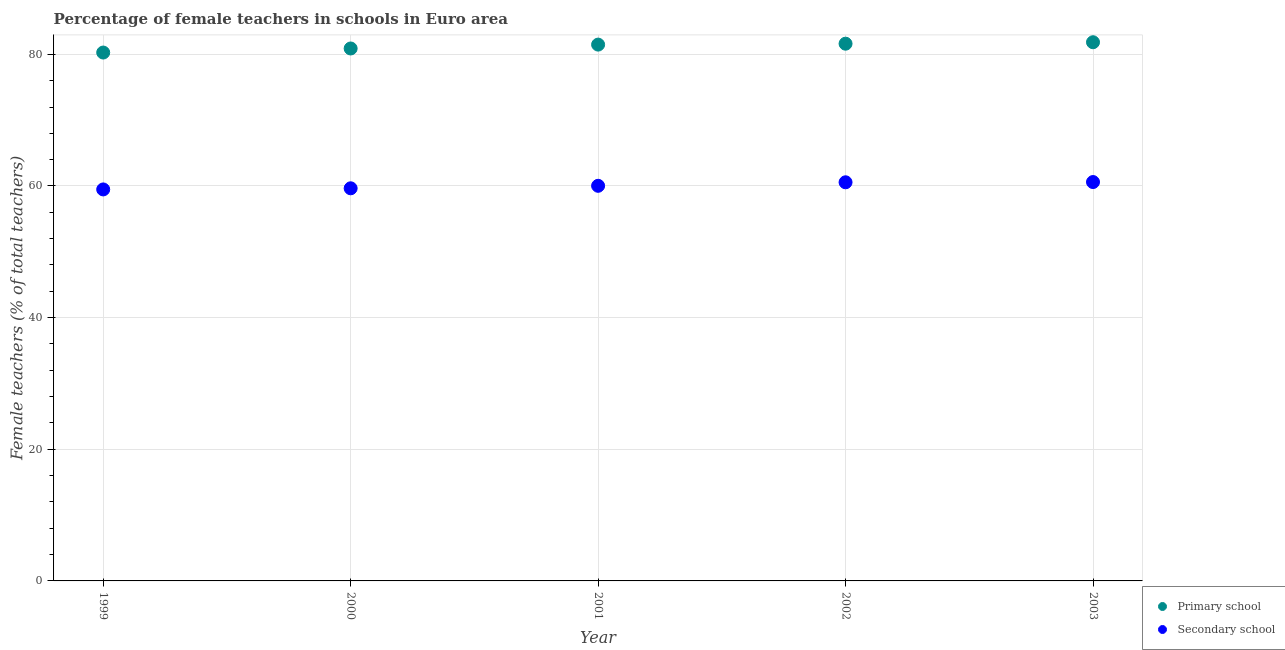What is the percentage of female teachers in secondary schools in 2002?
Your answer should be very brief. 60.56. Across all years, what is the maximum percentage of female teachers in secondary schools?
Keep it short and to the point. 60.6. Across all years, what is the minimum percentage of female teachers in secondary schools?
Your response must be concise. 59.48. What is the total percentage of female teachers in secondary schools in the graph?
Offer a terse response. 300.32. What is the difference between the percentage of female teachers in secondary schools in 2001 and that in 2002?
Your answer should be very brief. -0.53. What is the difference between the percentage of female teachers in secondary schools in 1999 and the percentage of female teachers in primary schools in 2000?
Your response must be concise. -21.41. What is the average percentage of female teachers in primary schools per year?
Offer a terse response. 81.22. In the year 2003, what is the difference between the percentage of female teachers in primary schools and percentage of female teachers in secondary schools?
Keep it short and to the point. 21.24. In how many years, is the percentage of female teachers in primary schools greater than 48 %?
Offer a very short reply. 5. What is the ratio of the percentage of female teachers in secondary schools in 2000 to that in 2003?
Provide a short and direct response. 0.98. Is the percentage of female teachers in secondary schools in 2000 less than that in 2001?
Provide a short and direct response. Yes. Is the difference between the percentage of female teachers in primary schools in 1999 and 2000 greater than the difference between the percentage of female teachers in secondary schools in 1999 and 2000?
Give a very brief answer. No. What is the difference between the highest and the second highest percentage of female teachers in primary schools?
Ensure brevity in your answer.  0.22. What is the difference between the highest and the lowest percentage of female teachers in secondary schools?
Provide a short and direct response. 1.12. In how many years, is the percentage of female teachers in secondary schools greater than the average percentage of female teachers in secondary schools taken over all years?
Provide a short and direct response. 2. Does the percentage of female teachers in secondary schools monotonically increase over the years?
Provide a short and direct response. Yes. Is the percentage of female teachers in primary schools strictly less than the percentage of female teachers in secondary schools over the years?
Provide a succinct answer. No. Are the values on the major ticks of Y-axis written in scientific E-notation?
Your answer should be compact. No. Does the graph contain any zero values?
Ensure brevity in your answer.  No. Where does the legend appear in the graph?
Provide a short and direct response. Bottom right. What is the title of the graph?
Give a very brief answer. Percentage of female teachers in schools in Euro area. What is the label or title of the Y-axis?
Your response must be concise. Female teachers (% of total teachers). What is the Female teachers (% of total teachers) in Primary school in 1999?
Provide a succinct answer. 80.27. What is the Female teachers (% of total teachers) of Secondary school in 1999?
Your answer should be compact. 59.48. What is the Female teachers (% of total teachers) in Primary school in 2000?
Keep it short and to the point. 80.89. What is the Female teachers (% of total teachers) in Secondary school in 2000?
Ensure brevity in your answer.  59.65. What is the Female teachers (% of total teachers) of Primary school in 2001?
Make the answer very short. 81.48. What is the Female teachers (% of total teachers) of Secondary school in 2001?
Your answer should be very brief. 60.03. What is the Female teachers (% of total teachers) in Primary school in 2002?
Your answer should be very brief. 81.62. What is the Female teachers (% of total teachers) of Secondary school in 2002?
Make the answer very short. 60.56. What is the Female teachers (% of total teachers) in Primary school in 2003?
Ensure brevity in your answer.  81.84. What is the Female teachers (% of total teachers) of Secondary school in 2003?
Ensure brevity in your answer.  60.6. Across all years, what is the maximum Female teachers (% of total teachers) of Primary school?
Your answer should be compact. 81.84. Across all years, what is the maximum Female teachers (% of total teachers) in Secondary school?
Your response must be concise. 60.6. Across all years, what is the minimum Female teachers (% of total teachers) in Primary school?
Give a very brief answer. 80.27. Across all years, what is the minimum Female teachers (% of total teachers) in Secondary school?
Offer a very short reply. 59.48. What is the total Female teachers (% of total teachers) of Primary school in the graph?
Give a very brief answer. 406.1. What is the total Female teachers (% of total teachers) in Secondary school in the graph?
Offer a very short reply. 300.32. What is the difference between the Female teachers (% of total teachers) in Primary school in 1999 and that in 2000?
Provide a succinct answer. -0.62. What is the difference between the Female teachers (% of total teachers) in Secondary school in 1999 and that in 2000?
Offer a terse response. -0.17. What is the difference between the Female teachers (% of total teachers) of Primary school in 1999 and that in 2001?
Your answer should be very brief. -1.21. What is the difference between the Female teachers (% of total teachers) in Secondary school in 1999 and that in 2001?
Your response must be concise. -0.55. What is the difference between the Female teachers (% of total teachers) in Primary school in 1999 and that in 2002?
Your answer should be compact. -1.34. What is the difference between the Female teachers (% of total teachers) of Secondary school in 1999 and that in 2002?
Provide a succinct answer. -1.08. What is the difference between the Female teachers (% of total teachers) of Primary school in 1999 and that in 2003?
Provide a succinct answer. -1.57. What is the difference between the Female teachers (% of total teachers) of Secondary school in 1999 and that in 2003?
Your answer should be very brief. -1.12. What is the difference between the Female teachers (% of total teachers) in Primary school in 2000 and that in 2001?
Ensure brevity in your answer.  -0.59. What is the difference between the Female teachers (% of total teachers) in Secondary school in 2000 and that in 2001?
Your response must be concise. -0.38. What is the difference between the Female teachers (% of total teachers) in Primary school in 2000 and that in 2002?
Provide a short and direct response. -0.73. What is the difference between the Female teachers (% of total teachers) of Secondary school in 2000 and that in 2002?
Your answer should be very brief. -0.91. What is the difference between the Female teachers (% of total teachers) of Primary school in 2000 and that in 2003?
Your response must be concise. -0.95. What is the difference between the Female teachers (% of total teachers) in Secondary school in 2000 and that in 2003?
Your answer should be very brief. -0.95. What is the difference between the Female teachers (% of total teachers) of Primary school in 2001 and that in 2002?
Offer a very short reply. -0.14. What is the difference between the Female teachers (% of total teachers) of Secondary school in 2001 and that in 2002?
Your answer should be compact. -0.53. What is the difference between the Female teachers (% of total teachers) in Primary school in 2001 and that in 2003?
Your answer should be compact. -0.36. What is the difference between the Female teachers (% of total teachers) in Secondary school in 2001 and that in 2003?
Make the answer very short. -0.57. What is the difference between the Female teachers (% of total teachers) of Primary school in 2002 and that in 2003?
Offer a terse response. -0.22. What is the difference between the Female teachers (% of total teachers) in Secondary school in 2002 and that in 2003?
Your answer should be compact. -0.04. What is the difference between the Female teachers (% of total teachers) in Primary school in 1999 and the Female teachers (% of total teachers) in Secondary school in 2000?
Make the answer very short. 20.62. What is the difference between the Female teachers (% of total teachers) in Primary school in 1999 and the Female teachers (% of total teachers) in Secondary school in 2001?
Your answer should be compact. 20.25. What is the difference between the Female teachers (% of total teachers) of Primary school in 1999 and the Female teachers (% of total teachers) of Secondary school in 2002?
Offer a very short reply. 19.71. What is the difference between the Female teachers (% of total teachers) of Primary school in 1999 and the Female teachers (% of total teachers) of Secondary school in 2003?
Give a very brief answer. 19.67. What is the difference between the Female teachers (% of total teachers) of Primary school in 2000 and the Female teachers (% of total teachers) of Secondary school in 2001?
Your answer should be very brief. 20.86. What is the difference between the Female teachers (% of total teachers) of Primary school in 2000 and the Female teachers (% of total teachers) of Secondary school in 2002?
Keep it short and to the point. 20.33. What is the difference between the Female teachers (% of total teachers) of Primary school in 2000 and the Female teachers (% of total teachers) of Secondary school in 2003?
Offer a very short reply. 20.29. What is the difference between the Female teachers (% of total teachers) in Primary school in 2001 and the Female teachers (% of total teachers) in Secondary school in 2002?
Offer a very short reply. 20.92. What is the difference between the Female teachers (% of total teachers) of Primary school in 2001 and the Female teachers (% of total teachers) of Secondary school in 2003?
Make the answer very short. 20.88. What is the difference between the Female teachers (% of total teachers) in Primary school in 2002 and the Female teachers (% of total teachers) in Secondary school in 2003?
Your response must be concise. 21.02. What is the average Female teachers (% of total teachers) of Primary school per year?
Your answer should be very brief. 81.22. What is the average Female teachers (% of total teachers) of Secondary school per year?
Your answer should be very brief. 60.06. In the year 1999, what is the difference between the Female teachers (% of total teachers) of Primary school and Female teachers (% of total teachers) of Secondary school?
Offer a very short reply. 20.8. In the year 2000, what is the difference between the Female teachers (% of total teachers) of Primary school and Female teachers (% of total teachers) of Secondary school?
Make the answer very short. 21.24. In the year 2001, what is the difference between the Female teachers (% of total teachers) in Primary school and Female teachers (% of total teachers) in Secondary school?
Ensure brevity in your answer.  21.45. In the year 2002, what is the difference between the Female teachers (% of total teachers) in Primary school and Female teachers (% of total teachers) in Secondary school?
Keep it short and to the point. 21.06. In the year 2003, what is the difference between the Female teachers (% of total teachers) in Primary school and Female teachers (% of total teachers) in Secondary school?
Make the answer very short. 21.24. What is the ratio of the Female teachers (% of total teachers) of Primary school in 1999 to that in 2000?
Your answer should be very brief. 0.99. What is the ratio of the Female teachers (% of total teachers) of Secondary school in 1999 to that in 2000?
Your response must be concise. 1. What is the ratio of the Female teachers (% of total teachers) in Primary school in 1999 to that in 2001?
Offer a terse response. 0.99. What is the ratio of the Female teachers (% of total teachers) in Primary school in 1999 to that in 2002?
Offer a terse response. 0.98. What is the ratio of the Female teachers (% of total teachers) in Secondary school in 1999 to that in 2002?
Your answer should be compact. 0.98. What is the ratio of the Female teachers (% of total teachers) of Primary school in 1999 to that in 2003?
Make the answer very short. 0.98. What is the ratio of the Female teachers (% of total teachers) of Secondary school in 1999 to that in 2003?
Offer a terse response. 0.98. What is the ratio of the Female teachers (% of total teachers) of Secondary school in 2000 to that in 2002?
Give a very brief answer. 0.98. What is the ratio of the Female teachers (% of total teachers) in Primary school in 2000 to that in 2003?
Offer a very short reply. 0.99. What is the ratio of the Female teachers (% of total teachers) in Secondary school in 2000 to that in 2003?
Provide a succinct answer. 0.98. What is the ratio of the Female teachers (% of total teachers) of Primary school in 2001 to that in 2002?
Offer a terse response. 1. What is the ratio of the Female teachers (% of total teachers) in Primary school in 2001 to that in 2003?
Your response must be concise. 1. What is the ratio of the Female teachers (% of total teachers) of Secondary school in 2001 to that in 2003?
Offer a very short reply. 0.99. What is the difference between the highest and the second highest Female teachers (% of total teachers) of Primary school?
Your answer should be very brief. 0.22. What is the difference between the highest and the second highest Female teachers (% of total teachers) in Secondary school?
Make the answer very short. 0.04. What is the difference between the highest and the lowest Female teachers (% of total teachers) of Primary school?
Give a very brief answer. 1.57. What is the difference between the highest and the lowest Female teachers (% of total teachers) in Secondary school?
Keep it short and to the point. 1.12. 